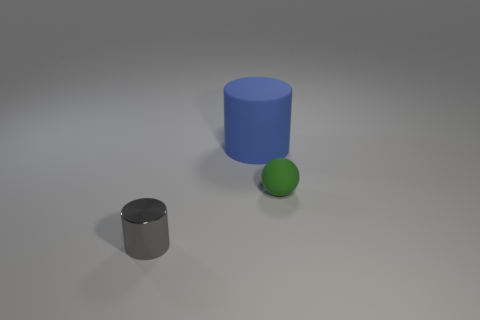Add 2 small rubber objects. How many objects exist? 5 Add 1 large blue rubber cylinders. How many large blue rubber cylinders exist? 2 Subtract 0 gray spheres. How many objects are left? 3 Subtract all cylinders. How many objects are left? 1 Subtract 1 cylinders. How many cylinders are left? 1 Subtract all gray cylinders. Subtract all purple cubes. How many cylinders are left? 1 Subtract all big purple objects. Subtract all large objects. How many objects are left? 2 Add 3 tiny cylinders. How many tiny cylinders are left? 4 